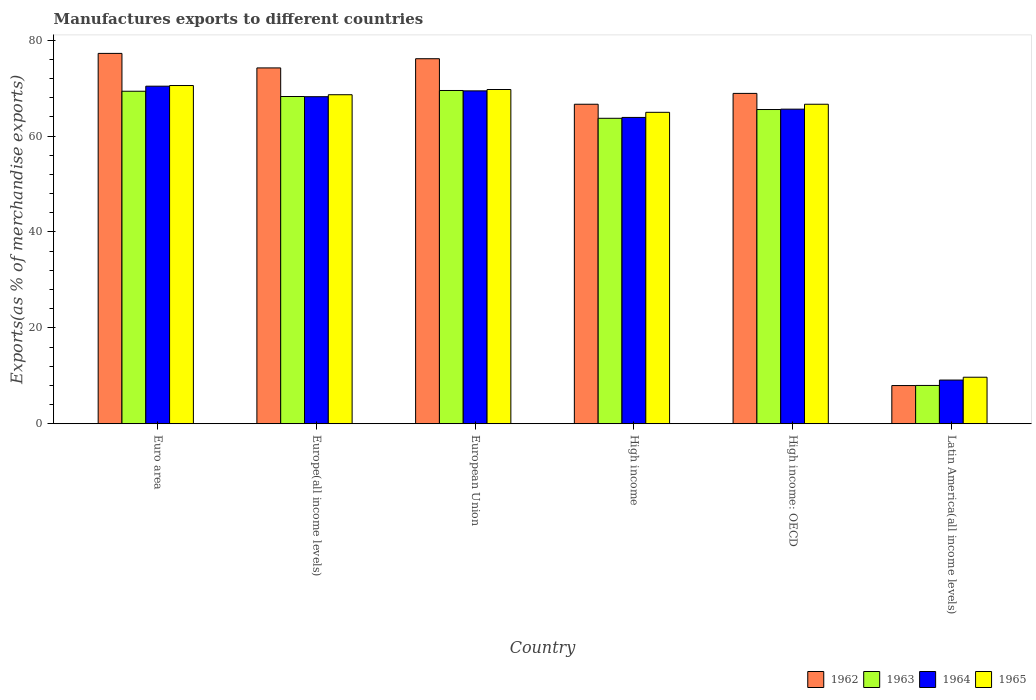How many different coloured bars are there?
Your response must be concise. 4. How many bars are there on the 1st tick from the left?
Offer a terse response. 4. How many bars are there on the 2nd tick from the right?
Give a very brief answer. 4. What is the percentage of exports to different countries in 1964 in Latin America(all income levels)?
Make the answer very short. 9.11. Across all countries, what is the maximum percentage of exports to different countries in 1964?
Your answer should be compact. 70.41. Across all countries, what is the minimum percentage of exports to different countries in 1965?
Keep it short and to the point. 9.7. In which country was the percentage of exports to different countries in 1962 maximum?
Provide a succinct answer. Euro area. In which country was the percentage of exports to different countries in 1963 minimum?
Provide a succinct answer. Latin America(all income levels). What is the total percentage of exports to different countries in 1963 in the graph?
Your response must be concise. 344.34. What is the difference between the percentage of exports to different countries in 1962 in European Union and that in Latin America(all income levels)?
Make the answer very short. 68.17. What is the difference between the percentage of exports to different countries in 1963 in Latin America(all income levels) and the percentage of exports to different countries in 1965 in Europe(all income levels)?
Your response must be concise. -60.63. What is the average percentage of exports to different countries in 1964 per country?
Provide a succinct answer. 57.78. What is the difference between the percentage of exports to different countries of/in 1964 and percentage of exports to different countries of/in 1965 in European Union?
Offer a terse response. -0.28. What is the ratio of the percentage of exports to different countries in 1962 in Europe(all income levels) to that in European Union?
Offer a very short reply. 0.97. Is the difference between the percentage of exports to different countries in 1964 in Euro area and High income: OECD greater than the difference between the percentage of exports to different countries in 1965 in Euro area and High income: OECD?
Give a very brief answer. Yes. What is the difference between the highest and the second highest percentage of exports to different countries in 1964?
Keep it short and to the point. -1.22. What is the difference between the highest and the lowest percentage of exports to different countries in 1962?
Your answer should be very brief. 69.28. Is the sum of the percentage of exports to different countries in 1962 in European Union and High income: OECD greater than the maximum percentage of exports to different countries in 1963 across all countries?
Provide a short and direct response. Yes. Is it the case that in every country, the sum of the percentage of exports to different countries in 1963 and percentage of exports to different countries in 1965 is greater than the percentage of exports to different countries in 1962?
Provide a short and direct response. Yes. How many countries are there in the graph?
Your response must be concise. 6. What is the difference between two consecutive major ticks on the Y-axis?
Keep it short and to the point. 20. Are the values on the major ticks of Y-axis written in scientific E-notation?
Provide a succinct answer. No. Does the graph contain grids?
Give a very brief answer. No. Where does the legend appear in the graph?
Offer a very short reply. Bottom right. How many legend labels are there?
Make the answer very short. 4. How are the legend labels stacked?
Give a very brief answer. Horizontal. What is the title of the graph?
Provide a succinct answer. Manufactures exports to different countries. What is the label or title of the Y-axis?
Offer a very short reply. Exports(as % of merchandise exports). What is the Exports(as % of merchandise exports) in 1962 in Euro area?
Ensure brevity in your answer.  77.24. What is the Exports(as % of merchandise exports) in 1963 in Euro area?
Give a very brief answer. 69.35. What is the Exports(as % of merchandise exports) in 1964 in Euro area?
Provide a succinct answer. 70.41. What is the Exports(as % of merchandise exports) of 1965 in Euro area?
Your response must be concise. 70.54. What is the Exports(as % of merchandise exports) of 1962 in Europe(all income levels)?
Offer a very short reply. 74.21. What is the Exports(as % of merchandise exports) in 1963 in Europe(all income levels)?
Your answer should be compact. 68.25. What is the Exports(as % of merchandise exports) of 1964 in Europe(all income levels)?
Give a very brief answer. 68.21. What is the Exports(as % of merchandise exports) of 1965 in Europe(all income levels)?
Your response must be concise. 68.62. What is the Exports(as % of merchandise exports) of 1962 in European Union?
Ensure brevity in your answer.  76.13. What is the Exports(as % of merchandise exports) of 1963 in European Union?
Your answer should be compact. 69.51. What is the Exports(as % of merchandise exports) in 1964 in European Union?
Offer a terse response. 69.43. What is the Exports(as % of merchandise exports) in 1965 in European Union?
Offer a very short reply. 69.71. What is the Exports(as % of merchandise exports) of 1962 in High income?
Give a very brief answer. 66.64. What is the Exports(as % of merchandise exports) of 1963 in High income?
Ensure brevity in your answer.  63.71. What is the Exports(as % of merchandise exports) of 1964 in High income?
Ensure brevity in your answer.  63.89. What is the Exports(as % of merchandise exports) in 1965 in High income?
Ensure brevity in your answer.  64.96. What is the Exports(as % of merchandise exports) of 1962 in High income: OECD?
Offer a very short reply. 68.9. What is the Exports(as % of merchandise exports) of 1963 in High income: OECD?
Offer a very short reply. 65.54. What is the Exports(as % of merchandise exports) of 1964 in High income: OECD?
Offer a terse response. 65.61. What is the Exports(as % of merchandise exports) in 1965 in High income: OECD?
Make the answer very short. 66.64. What is the Exports(as % of merchandise exports) of 1962 in Latin America(all income levels)?
Your answer should be compact. 7.96. What is the Exports(as % of merchandise exports) of 1963 in Latin America(all income levels)?
Provide a short and direct response. 7.99. What is the Exports(as % of merchandise exports) in 1964 in Latin America(all income levels)?
Keep it short and to the point. 9.11. What is the Exports(as % of merchandise exports) in 1965 in Latin America(all income levels)?
Your response must be concise. 9.7. Across all countries, what is the maximum Exports(as % of merchandise exports) in 1962?
Give a very brief answer. 77.24. Across all countries, what is the maximum Exports(as % of merchandise exports) in 1963?
Your answer should be very brief. 69.51. Across all countries, what is the maximum Exports(as % of merchandise exports) of 1964?
Offer a very short reply. 70.41. Across all countries, what is the maximum Exports(as % of merchandise exports) of 1965?
Your response must be concise. 70.54. Across all countries, what is the minimum Exports(as % of merchandise exports) of 1962?
Provide a succinct answer. 7.96. Across all countries, what is the minimum Exports(as % of merchandise exports) in 1963?
Make the answer very short. 7.99. Across all countries, what is the minimum Exports(as % of merchandise exports) of 1964?
Your response must be concise. 9.11. Across all countries, what is the minimum Exports(as % of merchandise exports) in 1965?
Offer a very short reply. 9.7. What is the total Exports(as % of merchandise exports) in 1962 in the graph?
Make the answer very short. 371.09. What is the total Exports(as % of merchandise exports) of 1963 in the graph?
Make the answer very short. 344.34. What is the total Exports(as % of merchandise exports) in 1964 in the graph?
Provide a short and direct response. 346.66. What is the total Exports(as % of merchandise exports) of 1965 in the graph?
Your answer should be very brief. 350.17. What is the difference between the Exports(as % of merchandise exports) in 1962 in Euro area and that in Europe(all income levels)?
Your answer should be compact. 3.03. What is the difference between the Exports(as % of merchandise exports) in 1963 in Euro area and that in Europe(all income levels)?
Give a very brief answer. 1.1. What is the difference between the Exports(as % of merchandise exports) of 1964 in Euro area and that in Europe(all income levels)?
Make the answer very short. 2.19. What is the difference between the Exports(as % of merchandise exports) in 1965 in Euro area and that in Europe(all income levels)?
Your answer should be very brief. 1.92. What is the difference between the Exports(as % of merchandise exports) of 1962 in Euro area and that in European Union?
Your answer should be compact. 1.11. What is the difference between the Exports(as % of merchandise exports) in 1963 in Euro area and that in European Union?
Your answer should be compact. -0.16. What is the difference between the Exports(as % of merchandise exports) in 1964 in Euro area and that in European Union?
Make the answer very short. 0.98. What is the difference between the Exports(as % of merchandise exports) of 1965 in Euro area and that in European Union?
Make the answer very short. 0.83. What is the difference between the Exports(as % of merchandise exports) of 1962 in Euro area and that in High income?
Offer a terse response. 10.6. What is the difference between the Exports(as % of merchandise exports) in 1963 in Euro area and that in High income?
Give a very brief answer. 5.64. What is the difference between the Exports(as % of merchandise exports) in 1964 in Euro area and that in High income?
Keep it short and to the point. 6.52. What is the difference between the Exports(as % of merchandise exports) in 1965 in Euro area and that in High income?
Offer a terse response. 5.59. What is the difference between the Exports(as % of merchandise exports) of 1962 in Euro area and that in High income: OECD?
Make the answer very short. 8.35. What is the difference between the Exports(as % of merchandise exports) of 1963 in Euro area and that in High income: OECD?
Give a very brief answer. 3.81. What is the difference between the Exports(as % of merchandise exports) of 1964 in Euro area and that in High income: OECD?
Your response must be concise. 4.79. What is the difference between the Exports(as % of merchandise exports) of 1965 in Euro area and that in High income: OECD?
Ensure brevity in your answer.  3.91. What is the difference between the Exports(as % of merchandise exports) in 1962 in Euro area and that in Latin America(all income levels)?
Your answer should be very brief. 69.28. What is the difference between the Exports(as % of merchandise exports) of 1963 in Euro area and that in Latin America(all income levels)?
Ensure brevity in your answer.  61.36. What is the difference between the Exports(as % of merchandise exports) of 1964 in Euro area and that in Latin America(all income levels)?
Offer a very short reply. 61.3. What is the difference between the Exports(as % of merchandise exports) in 1965 in Euro area and that in Latin America(all income levels)?
Your answer should be compact. 60.84. What is the difference between the Exports(as % of merchandise exports) of 1962 in Europe(all income levels) and that in European Union?
Offer a terse response. -1.92. What is the difference between the Exports(as % of merchandise exports) of 1963 in Europe(all income levels) and that in European Union?
Provide a succinct answer. -1.26. What is the difference between the Exports(as % of merchandise exports) in 1964 in Europe(all income levels) and that in European Union?
Keep it short and to the point. -1.22. What is the difference between the Exports(as % of merchandise exports) of 1965 in Europe(all income levels) and that in European Union?
Your response must be concise. -1.09. What is the difference between the Exports(as % of merchandise exports) in 1962 in Europe(all income levels) and that in High income?
Your answer should be compact. 7.57. What is the difference between the Exports(as % of merchandise exports) in 1963 in Europe(all income levels) and that in High income?
Your answer should be compact. 4.54. What is the difference between the Exports(as % of merchandise exports) in 1964 in Europe(all income levels) and that in High income?
Your answer should be compact. 4.33. What is the difference between the Exports(as % of merchandise exports) of 1965 in Europe(all income levels) and that in High income?
Provide a succinct answer. 3.67. What is the difference between the Exports(as % of merchandise exports) of 1962 in Europe(all income levels) and that in High income: OECD?
Ensure brevity in your answer.  5.32. What is the difference between the Exports(as % of merchandise exports) in 1963 in Europe(all income levels) and that in High income: OECD?
Keep it short and to the point. 2.71. What is the difference between the Exports(as % of merchandise exports) in 1964 in Europe(all income levels) and that in High income: OECD?
Give a very brief answer. 2.6. What is the difference between the Exports(as % of merchandise exports) in 1965 in Europe(all income levels) and that in High income: OECD?
Your answer should be very brief. 1.99. What is the difference between the Exports(as % of merchandise exports) in 1962 in Europe(all income levels) and that in Latin America(all income levels)?
Make the answer very short. 66.25. What is the difference between the Exports(as % of merchandise exports) in 1963 in Europe(all income levels) and that in Latin America(all income levels)?
Ensure brevity in your answer.  60.26. What is the difference between the Exports(as % of merchandise exports) of 1964 in Europe(all income levels) and that in Latin America(all income levels)?
Provide a succinct answer. 59.1. What is the difference between the Exports(as % of merchandise exports) of 1965 in Europe(all income levels) and that in Latin America(all income levels)?
Keep it short and to the point. 58.92. What is the difference between the Exports(as % of merchandise exports) of 1962 in European Union and that in High income?
Make the answer very short. 9.49. What is the difference between the Exports(as % of merchandise exports) of 1963 in European Union and that in High income?
Your response must be concise. 5.8. What is the difference between the Exports(as % of merchandise exports) of 1964 in European Union and that in High income?
Your answer should be compact. 5.54. What is the difference between the Exports(as % of merchandise exports) of 1965 in European Union and that in High income?
Ensure brevity in your answer.  4.76. What is the difference between the Exports(as % of merchandise exports) in 1962 in European Union and that in High income: OECD?
Offer a very short reply. 7.23. What is the difference between the Exports(as % of merchandise exports) in 1963 in European Union and that in High income: OECD?
Your answer should be very brief. 3.97. What is the difference between the Exports(as % of merchandise exports) in 1964 in European Union and that in High income: OECD?
Provide a succinct answer. 3.81. What is the difference between the Exports(as % of merchandise exports) of 1965 in European Union and that in High income: OECD?
Provide a short and direct response. 3.07. What is the difference between the Exports(as % of merchandise exports) of 1962 in European Union and that in Latin America(all income levels)?
Keep it short and to the point. 68.17. What is the difference between the Exports(as % of merchandise exports) of 1963 in European Union and that in Latin America(all income levels)?
Your response must be concise. 61.52. What is the difference between the Exports(as % of merchandise exports) in 1964 in European Union and that in Latin America(all income levels)?
Your answer should be compact. 60.32. What is the difference between the Exports(as % of merchandise exports) of 1965 in European Union and that in Latin America(all income levels)?
Your answer should be very brief. 60.01. What is the difference between the Exports(as % of merchandise exports) of 1962 in High income and that in High income: OECD?
Make the answer very short. -2.26. What is the difference between the Exports(as % of merchandise exports) in 1963 in High income and that in High income: OECD?
Provide a succinct answer. -1.83. What is the difference between the Exports(as % of merchandise exports) of 1964 in High income and that in High income: OECD?
Provide a short and direct response. -1.73. What is the difference between the Exports(as % of merchandise exports) in 1965 in High income and that in High income: OECD?
Keep it short and to the point. -1.68. What is the difference between the Exports(as % of merchandise exports) in 1962 in High income and that in Latin America(all income levels)?
Offer a very short reply. 58.68. What is the difference between the Exports(as % of merchandise exports) of 1963 in High income and that in Latin America(all income levels)?
Offer a terse response. 55.72. What is the difference between the Exports(as % of merchandise exports) of 1964 in High income and that in Latin America(all income levels)?
Provide a succinct answer. 54.78. What is the difference between the Exports(as % of merchandise exports) in 1965 in High income and that in Latin America(all income levels)?
Ensure brevity in your answer.  55.25. What is the difference between the Exports(as % of merchandise exports) of 1962 in High income: OECD and that in Latin America(all income levels)?
Your answer should be very brief. 60.93. What is the difference between the Exports(as % of merchandise exports) of 1963 in High income: OECD and that in Latin America(all income levels)?
Your answer should be compact. 57.55. What is the difference between the Exports(as % of merchandise exports) of 1964 in High income: OECD and that in Latin America(all income levels)?
Offer a terse response. 56.5. What is the difference between the Exports(as % of merchandise exports) of 1965 in High income: OECD and that in Latin America(all income levels)?
Give a very brief answer. 56.94. What is the difference between the Exports(as % of merchandise exports) in 1962 in Euro area and the Exports(as % of merchandise exports) in 1963 in Europe(all income levels)?
Your response must be concise. 8.99. What is the difference between the Exports(as % of merchandise exports) of 1962 in Euro area and the Exports(as % of merchandise exports) of 1964 in Europe(all income levels)?
Make the answer very short. 9.03. What is the difference between the Exports(as % of merchandise exports) in 1962 in Euro area and the Exports(as % of merchandise exports) in 1965 in Europe(all income levels)?
Provide a short and direct response. 8.62. What is the difference between the Exports(as % of merchandise exports) of 1963 in Euro area and the Exports(as % of merchandise exports) of 1964 in Europe(all income levels)?
Your response must be concise. 1.14. What is the difference between the Exports(as % of merchandise exports) in 1963 in Euro area and the Exports(as % of merchandise exports) in 1965 in Europe(all income levels)?
Offer a terse response. 0.73. What is the difference between the Exports(as % of merchandise exports) of 1964 in Euro area and the Exports(as % of merchandise exports) of 1965 in Europe(all income levels)?
Your answer should be compact. 1.78. What is the difference between the Exports(as % of merchandise exports) in 1962 in Euro area and the Exports(as % of merchandise exports) in 1963 in European Union?
Give a very brief answer. 7.74. What is the difference between the Exports(as % of merchandise exports) in 1962 in Euro area and the Exports(as % of merchandise exports) in 1964 in European Union?
Give a very brief answer. 7.82. What is the difference between the Exports(as % of merchandise exports) of 1962 in Euro area and the Exports(as % of merchandise exports) of 1965 in European Union?
Offer a terse response. 7.53. What is the difference between the Exports(as % of merchandise exports) of 1963 in Euro area and the Exports(as % of merchandise exports) of 1964 in European Union?
Your response must be concise. -0.08. What is the difference between the Exports(as % of merchandise exports) in 1963 in Euro area and the Exports(as % of merchandise exports) in 1965 in European Union?
Keep it short and to the point. -0.36. What is the difference between the Exports(as % of merchandise exports) of 1964 in Euro area and the Exports(as % of merchandise exports) of 1965 in European Union?
Your response must be concise. 0.69. What is the difference between the Exports(as % of merchandise exports) of 1962 in Euro area and the Exports(as % of merchandise exports) of 1963 in High income?
Offer a very short reply. 13.54. What is the difference between the Exports(as % of merchandise exports) in 1962 in Euro area and the Exports(as % of merchandise exports) in 1964 in High income?
Your answer should be compact. 13.36. What is the difference between the Exports(as % of merchandise exports) in 1962 in Euro area and the Exports(as % of merchandise exports) in 1965 in High income?
Provide a short and direct response. 12.29. What is the difference between the Exports(as % of merchandise exports) in 1963 in Euro area and the Exports(as % of merchandise exports) in 1964 in High income?
Provide a succinct answer. 5.46. What is the difference between the Exports(as % of merchandise exports) of 1963 in Euro area and the Exports(as % of merchandise exports) of 1965 in High income?
Ensure brevity in your answer.  4.39. What is the difference between the Exports(as % of merchandise exports) of 1964 in Euro area and the Exports(as % of merchandise exports) of 1965 in High income?
Provide a succinct answer. 5.45. What is the difference between the Exports(as % of merchandise exports) in 1962 in Euro area and the Exports(as % of merchandise exports) in 1963 in High income: OECD?
Your answer should be very brief. 11.71. What is the difference between the Exports(as % of merchandise exports) of 1962 in Euro area and the Exports(as % of merchandise exports) of 1964 in High income: OECD?
Keep it short and to the point. 11.63. What is the difference between the Exports(as % of merchandise exports) of 1962 in Euro area and the Exports(as % of merchandise exports) of 1965 in High income: OECD?
Make the answer very short. 10.61. What is the difference between the Exports(as % of merchandise exports) in 1963 in Euro area and the Exports(as % of merchandise exports) in 1964 in High income: OECD?
Give a very brief answer. 3.73. What is the difference between the Exports(as % of merchandise exports) of 1963 in Euro area and the Exports(as % of merchandise exports) of 1965 in High income: OECD?
Your response must be concise. 2.71. What is the difference between the Exports(as % of merchandise exports) of 1964 in Euro area and the Exports(as % of merchandise exports) of 1965 in High income: OECD?
Keep it short and to the point. 3.77. What is the difference between the Exports(as % of merchandise exports) in 1962 in Euro area and the Exports(as % of merchandise exports) in 1963 in Latin America(all income levels)?
Give a very brief answer. 69.26. What is the difference between the Exports(as % of merchandise exports) in 1962 in Euro area and the Exports(as % of merchandise exports) in 1964 in Latin America(all income levels)?
Provide a succinct answer. 68.13. What is the difference between the Exports(as % of merchandise exports) in 1962 in Euro area and the Exports(as % of merchandise exports) in 1965 in Latin America(all income levels)?
Ensure brevity in your answer.  67.54. What is the difference between the Exports(as % of merchandise exports) of 1963 in Euro area and the Exports(as % of merchandise exports) of 1964 in Latin America(all income levels)?
Make the answer very short. 60.24. What is the difference between the Exports(as % of merchandise exports) in 1963 in Euro area and the Exports(as % of merchandise exports) in 1965 in Latin America(all income levels)?
Provide a succinct answer. 59.65. What is the difference between the Exports(as % of merchandise exports) in 1964 in Euro area and the Exports(as % of merchandise exports) in 1965 in Latin America(all income levels)?
Provide a succinct answer. 60.71. What is the difference between the Exports(as % of merchandise exports) of 1962 in Europe(all income levels) and the Exports(as % of merchandise exports) of 1963 in European Union?
Provide a short and direct response. 4.71. What is the difference between the Exports(as % of merchandise exports) in 1962 in Europe(all income levels) and the Exports(as % of merchandise exports) in 1964 in European Union?
Ensure brevity in your answer.  4.79. What is the difference between the Exports(as % of merchandise exports) in 1962 in Europe(all income levels) and the Exports(as % of merchandise exports) in 1965 in European Union?
Offer a terse response. 4.5. What is the difference between the Exports(as % of merchandise exports) of 1963 in Europe(all income levels) and the Exports(as % of merchandise exports) of 1964 in European Union?
Your answer should be compact. -1.18. What is the difference between the Exports(as % of merchandise exports) in 1963 in Europe(all income levels) and the Exports(as % of merchandise exports) in 1965 in European Union?
Your response must be concise. -1.46. What is the difference between the Exports(as % of merchandise exports) in 1964 in Europe(all income levels) and the Exports(as % of merchandise exports) in 1965 in European Union?
Provide a short and direct response. -1.5. What is the difference between the Exports(as % of merchandise exports) of 1962 in Europe(all income levels) and the Exports(as % of merchandise exports) of 1963 in High income?
Your answer should be compact. 10.51. What is the difference between the Exports(as % of merchandise exports) of 1962 in Europe(all income levels) and the Exports(as % of merchandise exports) of 1964 in High income?
Provide a short and direct response. 10.33. What is the difference between the Exports(as % of merchandise exports) in 1962 in Europe(all income levels) and the Exports(as % of merchandise exports) in 1965 in High income?
Offer a terse response. 9.26. What is the difference between the Exports(as % of merchandise exports) of 1963 in Europe(all income levels) and the Exports(as % of merchandise exports) of 1964 in High income?
Your answer should be very brief. 4.36. What is the difference between the Exports(as % of merchandise exports) of 1963 in Europe(all income levels) and the Exports(as % of merchandise exports) of 1965 in High income?
Offer a terse response. 3.3. What is the difference between the Exports(as % of merchandise exports) of 1964 in Europe(all income levels) and the Exports(as % of merchandise exports) of 1965 in High income?
Offer a terse response. 3.26. What is the difference between the Exports(as % of merchandise exports) of 1962 in Europe(all income levels) and the Exports(as % of merchandise exports) of 1963 in High income: OECD?
Offer a terse response. 8.68. What is the difference between the Exports(as % of merchandise exports) in 1962 in Europe(all income levels) and the Exports(as % of merchandise exports) in 1964 in High income: OECD?
Make the answer very short. 8.6. What is the difference between the Exports(as % of merchandise exports) in 1962 in Europe(all income levels) and the Exports(as % of merchandise exports) in 1965 in High income: OECD?
Keep it short and to the point. 7.58. What is the difference between the Exports(as % of merchandise exports) of 1963 in Europe(all income levels) and the Exports(as % of merchandise exports) of 1964 in High income: OECD?
Keep it short and to the point. 2.64. What is the difference between the Exports(as % of merchandise exports) of 1963 in Europe(all income levels) and the Exports(as % of merchandise exports) of 1965 in High income: OECD?
Make the answer very short. 1.61. What is the difference between the Exports(as % of merchandise exports) in 1964 in Europe(all income levels) and the Exports(as % of merchandise exports) in 1965 in High income: OECD?
Provide a succinct answer. 1.57. What is the difference between the Exports(as % of merchandise exports) in 1962 in Europe(all income levels) and the Exports(as % of merchandise exports) in 1963 in Latin America(all income levels)?
Offer a terse response. 66.23. What is the difference between the Exports(as % of merchandise exports) in 1962 in Europe(all income levels) and the Exports(as % of merchandise exports) in 1964 in Latin America(all income levels)?
Make the answer very short. 65.1. What is the difference between the Exports(as % of merchandise exports) in 1962 in Europe(all income levels) and the Exports(as % of merchandise exports) in 1965 in Latin America(all income levels)?
Make the answer very short. 64.51. What is the difference between the Exports(as % of merchandise exports) of 1963 in Europe(all income levels) and the Exports(as % of merchandise exports) of 1964 in Latin America(all income levels)?
Your response must be concise. 59.14. What is the difference between the Exports(as % of merchandise exports) in 1963 in Europe(all income levels) and the Exports(as % of merchandise exports) in 1965 in Latin America(all income levels)?
Make the answer very short. 58.55. What is the difference between the Exports(as % of merchandise exports) in 1964 in Europe(all income levels) and the Exports(as % of merchandise exports) in 1965 in Latin America(all income levels)?
Your response must be concise. 58.51. What is the difference between the Exports(as % of merchandise exports) in 1962 in European Union and the Exports(as % of merchandise exports) in 1963 in High income?
Provide a short and direct response. 12.42. What is the difference between the Exports(as % of merchandise exports) of 1962 in European Union and the Exports(as % of merchandise exports) of 1964 in High income?
Make the answer very short. 12.25. What is the difference between the Exports(as % of merchandise exports) in 1962 in European Union and the Exports(as % of merchandise exports) in 1965 in High income?
Your answer should be compact. 11.18. What is the difference between the Exports(as % of merchandise exports) in 1963 in European Union and the Exports(as % of merchandise exports) in 1964 in High income?
Provide a short and direct response. 5.62. What is the difference between the Exports(as % of merchandise exports) in 1963 in European Union and the Exports(as % of merchandise exports) in 1965 in High income?
Make the answer very short. 4.55. What is the difference between the Exports(as % of merchandise exports) in 1964 in European Union and the Exports(as % of merchandise exports) in 1965 in High income?
Offer a terse response. 4.47. What is the difference between the Exports(as % of merchandise exports) of 1962 in European Union and the Exports(as % of merchandise exports) of 1963 in High income: OECD?
Offer a terse response. 10.59. What is the difference between the Exports(as % of merchandise exports) in 1962 in European Union and the Exports(as % of merchandise exports) in 1964 in High income: OECD?
Keep it short and to the point. 10.52. What is the difference between the Exports(as % of merchandise exports) in 1962 in European Union and the Exports(as % of merchandise exports) in 1965 in High income: OECD?
Your response must be concise. 9.5. What is the difference between the Exports(as % of merchandise exports) in 1963 in European Union and the Exports(as % of merchandise exports) in 1964 in High income: OECD?
Ensure brevity in your answer.  3.89. What is the difference between the Exports(as % of merchandise exports) in 1963 in European Union and the Exports(as % of merchandise exports) in 1965 in High income: OECD?
Offer a terse response. 2.87. What is the difference between the Exports(as % of merchandise exports) in 1964 in European Union and the Exports(as % of merchandise exports) in 1965 in High income: OECD?
Make the answer very short. 2.79. What is the difference between the Exports(as % of merchandise exports) of 1962 in European Union and the Exports(as % of merchandise exports) of 1963 in Latin America(all income levels)?
Provide a short and direct response. 68.14. What is the difference between the Exports(as % of merchandise exports) of 1962 in European Union and the Exports(as % of merchandise exports) of 1964 in Latin America(all income levels)?
Make the answer very short. 67.02. What is the difference between the Exports(as % of merchandise exports) of 1962 in European Union and the Exports(as % of merchandise exports) of 1965 in Latin America(all income levels)?
Give a very brief answer. 66.43. What is the difference between the Exports(as % of merchandise exports) of 1963 in European Union and the Exports(as % of merchandise exports) of 1964 in Latin America(all income levels)?
Give a very brief answer. 60.4. What is the difference between the Exports(as % of merchandise exports) of 1963 in European Union and the Exports(as % of merchandise exports) of 1965 in Latin America(all income levels)?
Your answer should be very brief. 59.81. What is the difference between the Exports(as % of merchandise exports) in 1964 in European Union and the Exports(as % of merchandise exports) in 1965 in Latin America(all income levels)?
Keep it short and to the point. 59.73. What is the difference between the Exports(as % of merchandise exports) of 1962 in High income and the Exports(as % of merchandise exports) of 1963 in High income: OECD?
Offer a terse response. 1.1. What is the difference between the Exports(as % of merchandise exports) in 1962 in High income and the Exports(as % of merchandise exports) in 1964 in High income: OECD?
Provide a short and direct response. 1.03. What is the difference between the Exports(as % of merchandise exports) of 1962 in High income and the Exports(as % of merchandise exports) of 1965 in High income: OECD?
Provide a succinct answer. 0. What is the difference between the Exports(as % of merchandise exports) in 1963 in High income and the Exports(as % of merchandise exports) in 1964 in High income: OECD?
Offer a terse response. -1.91. What is the difference between the Exports(as % of merchandise exports) in 1963 in High income and the Exports(as % of merchandise exports) in 1965 in High income: OECD?
Ensure brevity in your answer.  -2.93. What is the difference between the Exports(as % of merchandise exports) in 1964 in High income and the Exports(as % of merchandise exports) in 1965 in High income: OECD?
Provide a succinct answer. -2.75. What is the difference between the Exports(as % of merchandise exports) of 1962 in High income and the Exports(as % of merchandise exports) of 1963 in Latin America(all income levels)?
Give a very brief answer. 58.65. What is the difference between the Exports(as % of merchandise exports) in 1962 in High income and the Exports(as % of merchandise exports) in 1964 in Latin America(all income levels)?
Your answer should be very brief. 57.53. What is the difference between the Exports(as % of merchandise exports) of 1962 in High income and the Exports(as % of merchandise exports) of 1965 in Latin America(all income levels)?
Give a very brief answer. 56.94. What is the difference between the Exports(as % of merchandise exports) in 1963 in High income and the Exports(as % of merchandise exports) in 1964 in Latin America(all income levels)?
Keep it short and to the point. 54.6. What is the difference between the Exports(as % of merchandise exports) of 1963 in High income and the Exports(as % of merchandise exports) of 1965 in Latin America(all income levels)?
Provide a succinct answer. 54.01. What is the difference between the Exports(as % of merchandise exports) in 1964 in High income and the Exports(as % of merchandise exports) in 1965 in Latin America(all income levels)?
Provide a short and direct response. 54.19. What is the difference between the Exports(as % of merchandise exports) in 1962 in High income: OECD and the Exports(as % of merchandise exports) in 1963 in Latin America(all income levels)?
Provide a short and direct response. 60.91. What is the difference between the Exports(as % of merchandise exports) of 1962 in High income: OECD and the Exports(as % of merchandise exports) of 1964 in Latin America(all income levels)?
Provide a short and direct response. 59.79. What is the difference between the Exports(as % of merchandise exports) in 1962 in High income: OECD and the Exports(as % of merchandise exports) in 1965 in Latin America(all income levels)?
Provide a succinct answer. 59.2. What is the difference between the Exports(as % of merchandise exports) in 1963 in High income: OECD and the Exports(as % of merchandise exports) in 1964 in Latin America(all income levels)?
Give a very brief answer. 56.43. What is the difference between the Exports(as % of merchandise exports) in 1963 in High income: OECD and the Exports(as % of merchandise exports) in 1965 in Latin America(all income levels)?
Offer a very short reply. 55.84. What is the difference between the Exports(as % of merchandise exports) of 1964 in High income: OECD and the Exports(as % of merchandise exports) of 1965 in Latin America(all income levels)?
Make the answer very short. 55.91. What is the average Exports(as % of merchandise exports) in 1962 per country?
Provide a succinct answer. 61.85. What is the average Exports(as % of merchandise exports) in 1963 per country?
Provide a succinct answer. 57.39. What is the average Exports(as % of merchandise exports) of 1964 per country?
Provide a succinct answer. 57.78. What is the average Exports(as % of merchandise exports) of 1965 per country?
Your answer should be very brief. 58.36. What is the difference between the Exports(as % of merchandise exports) in 1962 and Exports(as % of merchandise exports) in 1963 in Euro area?
Ensure brevity in your answer.  7.9. What is the difference between the Exports(as % of merchandise exports) in 1962 and Exports(as % of merchandise exports) in 1964 in Euro area?
Provide a short and direct response. 6.84. What is the difference between the Exports(as % of merchandise exports) in 1962 and Exports(as % of merchandise exports) in 1965 in Euro area?
Provide a succinct answer. 6.7. What is the difference between the Exports(as % of merchandise exports) in 1963 and Exports(as % of merchandise exports) in 1964 in Euro area?
Keep it short and to the point. -1.06. What is the difference between the Exports(as % of merchandise exports) of 1963 and Exports(as % of merchandise exports) of 1965 in Euro area?
Ensure brevity in your answer.  -1.19. What is the difference between the Exports(as % of merchandise exports) of 1964 and Exports(as % of merchandise exports) of 1965 in Euro area?
Your answer should be compact. -0.14. What is the difference between the Exports(as % of merchandise exports) in 1962 and Exports(as % of merchandise exports) in 1963 in Europe(all income levels)?
Provide a short and direct response. 5.96. What is the difference between the Exports(as % of merchandise exports) of 1962 and Exports(as % of merchandise exports) of 1964 in Europe(all income levels)?
Provide a succinct answer. 6. What is the difference between the Exports(as % of merchandise exports) of 1962 and Exports(as % of merchandise exports) of 1965 in Europe(all income levels)?
Keep it short and to the point. 5.59. What is the difference between the Exports(as % of merchandise exports) in 1963 and Exports(as % of merchandise exports) in 1964 in Europe(all income levels)?
Keep it short and to the point. 0.04. What is the difference between the Exports(as % of merchandise exports) of 1963 and Exports(as % of merchandise exports) of 1965 in Europe(all income levels)?
Offer a terse response. -0.37. What is the difference between the Exports(as % of merchandise exports) of 1964 and Exports(as % of merchandise exports) of 1965 in Europe(all income levels)?
Offer a terse response. -0.41. What is the difference between the Exports(as % of merchandise exports) of 1962 and Exports(as % of merchandise exports) of 1963 in European Union?
Keep it short and to the point. 6.62. What is the difference between the Exports(as % of merchandise exports) in 1962 and Exports(as % of merchandise exports) in 1964 in European Union?
Keep it short and to the point. 6.71. What is the difference between the Exports(as % of merchandise exports) in 1962 and Exports(as % of merchandise exports) in 1965 in European Union?
Provide a short and direct response. 6.42. What is the difference between the Exports(as % of merchandise exports) of 1963 and Exports(as % of merchandise exports) of 1964 in European Union?
Provide a succinct answer. 0.08. What is the difference between the Exports(as % of merchandise exports) of 1963 and Exports(as % of merchandise exports) of 1965 in European Union?
Your response must be concise. -0.2. What is the difference between the Exports(as % of merchandise exports) of 1964 and Exports(as % of merchandise exports) of 1965 in European Union?
Keep it short and to the point. -0.28. What is the difference between the Exports(as % of merchandise exports) of 1962 and Exports(as % of merchandise exports) of 1963 in High income?
Ensure brevity in your answer.  2.93. What is the difference between the Exports(as % of merchandise exports) of 1962 and Exports(as % of merchandise exports) of 1964 in High income?
Ensure brevity in your answer.  2.75. What is the difference between the Exports(as % of merchandise exports) in 1962 and Exports(as % of merchandise exports) in 1965 in High income?
Keep it short and to the point. 1.68. What is the difference between the Exports(as % of merchandise exports) in 1963 and Exports(as % of merchandise exports) in 1964 in High income?
Your answer should be very brief. -0.18. What is the difference between the Exports(as % of merchandise exports) of 1963 and Exports(as % of merchandise exports) of 1965 in High income?
Your response must be concise. -1.25. What is the difference between the Exports(as % of merchandise exports) in 1964 and Exports(as % of merchandise exports) in 1965 in High income?
Your answer should be very brief. -1.07. What is the difference between the Exports(as % of merchandise exports) in 1962 and Exports(as % of merchandise exports) in 1963 in High income: OECD?
Offer a very short reply. 3.36. What is the difference between the Exports(as % of merchandise exports) in 1962 and Exports(as % of merchandise exports) in 1964 in High income: OECD?
Your answer should be very brief. 3.28. What is the difference between the Exports(as % of merchandise exports) of 1962 and Exports(as % of merchandise exports) of 1965 in High income: OECD?
Offer a terse response. 2.26. What is the difference between the Exports(as % of merchandise exports) of 1963 and Exports(as % of merchandise exports) of 1964 in High income: OECD?
Provide a succinct answer. -0.08. What is the difference between the Exports(as % of merchandise exports) of 1963 and Exports(as % of merchandise exports) of 1965 in High income: OECD?
Make the answer very short. -1.1. What is the difference between the Exports(as % of merchandise exports) of 1964 and Exports(as % of merchandise exports) of 1965 in High income: OECD?
Provide a short and direct response. -1.02. What is the difference between the Exports(as % of merchandise exports) of 1962 and Exports(as % of merchandise exports) of 1963 in Latin America(all income levels)?
Offer a very short reply. -0.02. What is the difference between the Exports(as % of merchandise exports) of 1962 and Exports(as % of merchandise exports) of 1964 in Latin America(all income levels)?
Give a very brief answer. -1.15. What is the difference between the Exports(as % of merchandise exports) in 1962 and Exports(as % of merchandise exports) in 1965 in Latin America(all income levels)?
Keep it short and to the point. -1.74. What is the difference between the Exports(as % of merchandise exports) in 1963 and Exports(as % of merchandise exports) in 1964 in Latin America(all income levels)?
Your answer should be compact. -1.12. What is the difference between the Exports(as % of merchandise exports) of 1963 and Exports(as % of merchandise exports) of 1965 in Latin America(all income levels)?
Your response must be concise. -1.71. What is the difference between the Exports(as % of merchandise exports) in 1964 and Exports(as % of merchandise exports) in 1965 in Latin America(all income levels)?
Offer a terse response. -0.59. What is the ratio of the Exports(as % of merchandise exports) of 1962 in Euro area to that in Europe(all income levels)?
Provide a short and direct response. 1.04. What is the ratio of the Exports(as % of merchandise exports) in 1963 in Euro area to that in Europe(all income levels)?
Provide a succinct answer. 1.02. What is the ratio of the Exports(as % of merchandise exports) of 1964 in Euro area to that in Europe(all income levels)?
Your answer should be very brief. 1.03. What is the ratio of the Exports(as % of merchandise exports) of 1965 in Euro area to that in Europe(all income levels)?
Provide a short and direct response. 1.03. What is the ratio of the Exports(as % of merchandise exports) in 1962 in Euro area to that in European Union?
Offer a terse response. 1.01. What is the ratio of the Exports(as % of merchandise exports) of 1963 in Euro area to that in European Union?
Your response must be concise. 1. What is the ratio of the Exports(as % of merchandise exports) of 1964 in Euro area to that in European Union?
Your response must be concise. 1.01. What is the ratio of the Exports(as % of merchandise exports) of 1965 in Euro area to that in European Union?
Your answer should be very brief. 1.01. What is the ratio of the Exports(as % of merchandise exports) in 1962 in Euro area to that in High income?
Your response must be concise. 1.16. What is the ratio of the Exports(as % of merchandise exports) of 1963 in Euro area to that in High income?
Give a very brief answer. 1.09. What is the ratio of the Exports(as % of merchandise exports) of 1964 in Euro area to that in High income?
Provide a short and direct response. 1.1. What is the ratio of the Exports(as % of merchandise exports) in 1965 in Euro area to that in High income?
Ensure brevity in your answer.  1.09. What is the ratio of the Exports(as % of merchandise exports) in 1962 in Euro area to that in High income: OECD?
Offer a very short reply. 1.12. What is the ratio of the Exports(as % of merchandise exports) in 1963 in Euro area to that in High income: OECD?
Make the answer very short. 1.06. What is the ratio of the Exports(as % of merchandise exports) in 1964 in Euro area to that in High income: OECD?
Give a very brief answer. 1.07. What is the ratio of the Exports(as % of merchandise exports) in 1965 in Euro area to that in High income: OECD?
Provide a succinct answer. 1.06. What is the ratio of the Exports(as % of merchandise exports) of 1962 in Euro area to that in Latin America(all income levels)?
Ensure brevity in your answer.  9.7. What is the ratio of the Exports(as % of merchandise exports) of 1963 in Euro area to that in Latin America(all income levels)?
Ensure brevity in your answer.  8.68. What is the ratio of the Exports(as % of merchandise exports) of 1964 in Euro area to that in Latin America(all income levels)?
Make the answer very short. 7.73. What is the ratio of the Exports(as % of merchandise exports) of 1965 in Euro area to that in Latin America(all income levels)?
Your response must be concise. 7.27. What is the ratio of the Exports(as % of merchandise exports) in 1962 in Europe(all income levels) to that in European Union?
Offer a very short reply. 0.97. What is the ratio of the Exports(as % of merchandise exports) in 1963 in Europe(all income levels) to that in European Union?
Give a very brief answer. 0.98. What is the ratio of the Exports(as % of merchandise exports) of 1964 in Europe(all income levels) to that in European Union?
Provide a succinct answer. 0.98. What is the ratio of the Exports(as % of merchandise exports) in 1965 in Europe(all income levels) to that in European Union?
Ensure brevity in your answer.  0.98. What is the ratio of the Exports(as % of merchandise exports) in 1962 in Europe(all income levels) to that in High income?
Your answer should be compact. 1.11. What is the ratio of the Exports(as % of merchandise exports) in 1963 in Europe(all income levels) to that in High income?
Make the answer very short. 1.07. What is the ratio of the Exports(as % of merchandise exports) in 1964 in Europe(all income levels) to that in High income?
Your answer should be very brief. 1.07. What is the ratio of the Exports(as % of merchandise exports) in 1965 in Europe(all income levels) to that in High income?
Ensure brevity in your answer.  1.06. What is the ratio of the Exports(as % of merchandise exports) of 1962 in Europe(all income levels) to that in High income: OECD?
Make the answer very short. 1.08. What is the ratio of the Exports(as % of merchandise exports) in 1963 in Europe(all income levels) to that in High income: OECD?
Provide a succinct answer. 1.04. What is the ratio of the Exports(as % of merchandise exports) in 1964 in Europe(all income levels) to that in High income: OECD?
Your answer should be very brief. 1.04. What is the ratio of the Exports(as % of merchandise exports) of 1965 in Europe(all income levels) to that in High income: OECD?
Make the answer very short. 1.03. What is the ratio of the Exports(as % of merchandise exports) of 1962 in Europe(all income levels) to that in Latin America(all income levels)?
Give a very brief answer. 9.32. What is the ratio of the Exports(as % of merchandise exports) of 1963 in Europe(all income levels) to that in Latin America(all income levels)?
Provide a short and direct response. 8.54. What is the ratio of the Exports(as % of merchandise exports) in 1964 in Europe(all income levels) to that in Latin America(all income levels)?
Your response must be concise. 7.49. What is the ratio of the Exports(as % of merchandise exports) of 1965 in Europe(all income levels) to that in Latin America(all income levels)?
Your answer should be compact. 7.07. What is the ratio of the Exports(as % of merchandise exports) of 1962 in European Union to that in High income?
Offer a very short reply. 1.14. What is the ratio of the Exports(as % of merchandise exports) of 1963 in European Union to that in High income?
Ensure brevity in your answer.  1.09. What is the ratio of the Exports(as % of merchandise exports) in 1964 in European Union to that in High income?
Keep it short and to the point. 1.09. What is the ratio of the Exports(as % of merchandise exports) of 1965 in European Union to that in High income?
Make the answer very short. 1.07. What is the ratio of the Exports(as % of merchandise exports) in 1962 in European Union to that in High income: OECD?
Your response must be concise. 1.1. What is the ratio of the Exports(as % of merchandise exports) of 1963 in European Union to that in High income: OECD?
Make the answer very short. 1.06. What is the ratio of the Exports(as % of merchandise exports) of 1964 in European Union to that in High income: OECD?
Your answer should be very brief. 1.06. What is the ratio of the Exports(as % of merchandise exports) of 1965 in European Union to that in High income: OECD?
Offer a very short reply. 1.05. What is the ratio of the Exports(as % of merchandise exports) in 1962 in European Union to that in Latin America(all income levels)?
Your answer should be very brief. 9.56. What is the ratio of the Exports(as % of merchandise exports) in 1963 in European Union to that in Latin America(all income levels)?
Give a very brief answer. 8.7. What is the ratio of the Exports(as % of merchandise exports) of 1964 in European Union to that in Latin America(all income levels)?
Your response must be concise. 7.62. What is the ratio of the Exports(as % of merchandise exports) of 1965 in European Union to that in Latin America(all income levels)?
Your answer should be compact. 7.19. What is the ratio of the Exports(as % of merchandise exports) in 1962 in High income to that in High income: OECD?
Your answer should be very brief. 0.97. What is the ratio of the Exports(as % of merchandise exports) of 1963 in High income to that in High income: OECD?
Provide a succinct answer. 0.97. What is the ratio of the Exports(as % of merchandise exports) of 1964 in High income to that in High income: OECD?
Offer a very short reply. 0.97. What is the ratio of the Exports(as % of merchandise exports) in 1965 in High income to that in High income: OECD?
Ensure brevity in your answer.  0.97. What is the ratio of the Exports(as % of merchandise exports) in 1962 in High income to that in Latin America(all income levels)?
Make the answer very short. 8.37. What is the ratio of the Exports(as % of merchandise exports) in 1963 in High income to that in Latin America(all income levels)?
Your response must be concise. 7.97. What is the ratio of the Exports(as % of merchandise exports) of 1964 in High income to that in Latin America(all income levels)?
Offer a terse response. 7.01. What is the ratio of the Exports(as % of merchandise exports) in 1965 in High income to that in Latin America(all income levels)?
Keep it short and to the point. 6.7. What is the ratio of the Exports(as % of merchandise exports) in 1962 in High income: OECD to that in Latin America(all income levels)?
Ensure brevity in your answer.  8.65. What is the ratio of the Exports(as % of merchandise exports) in 1963 in High income: OECD to that in Latin America(all income levels)?
Make the answer very short. 8.2. What is the ratio of the Exports(as % of merchandise exports) in 1964 in High income: OECD to that in Latin America(all income levels)?
Offer a very short reply. 7.2. What is the ratio of the Exports(as % of merchandise exports) of 1965 in High income: OECD to that in Latin America(all income levels)?
Your answer should be very brief. 6.87. What is the difference between the highest and the second highest Exports(as % of merchandise exports) in 1962?
Keep it short and to the point. 1.11. What is the difference between the highest and the second highest Exports(as % of merchandise exports) in 1963?
Give a very brief answer. 0.16. What is the difference between the highest and the second highest Exports(as % of merchandise exports) of 1964?
Your answer should be very brief. 0.98. What is the difference between the highest and the second highest Exports(as % of merchandise exports) in 1965?
Ensure brevity in your answer.  0.83. What is the difference between the highest and the lowest Exports(as % of merchandise exports) in 1962?
Your response must be concise. 69.28. What is the difference between the highest and the lowest Exports(as % of merchandise exports) in 1963?
Ensure brevity in your answer.  61.52. What is the difference between the highest and the lowest Exports(as % of merchandise exports) of 1964?
Your response must be concise. 61.3. What is the difference between the highest and the lowest Exports(as % of merchandise exports) in 1965?
Offer a terse response. 60.84. 